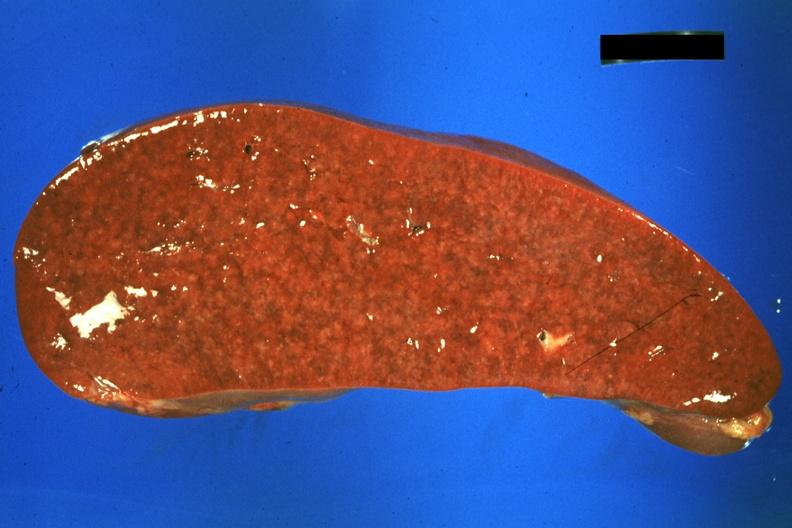s hematologic present?
Answer the question using a single word or phrase. Yes 